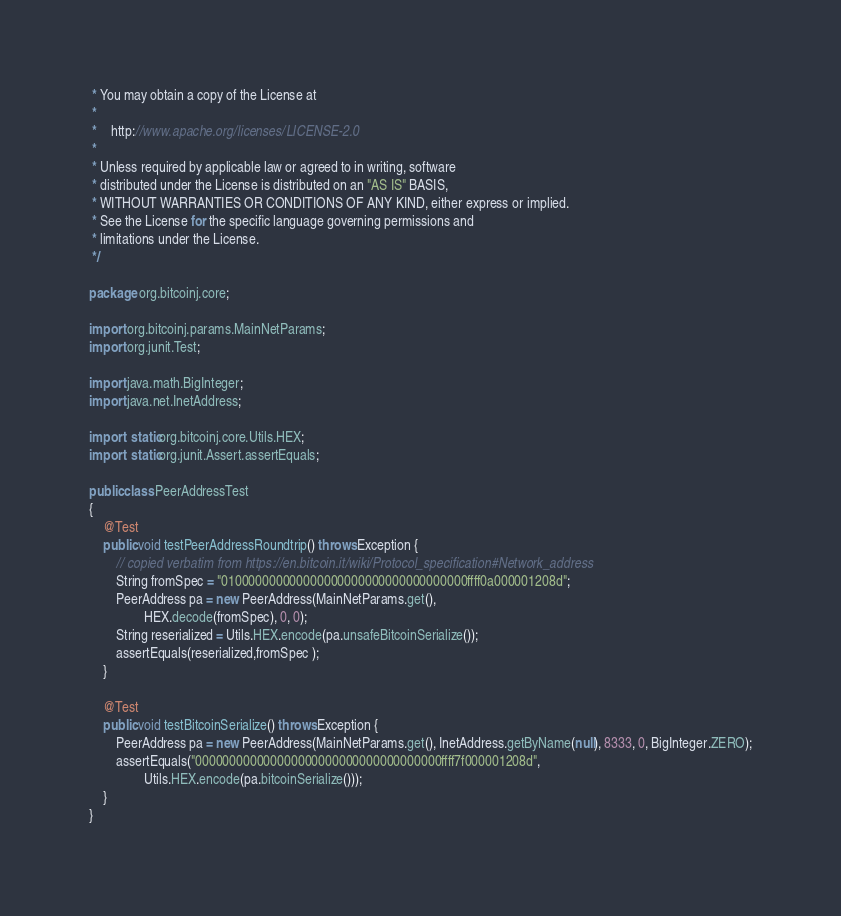Convert code to text. <code><loc_0><loc_0><loc_500><loc_500><_Java_> * You may obtain a copy of the License at
 *
 *    http://www.apache.org/licenses/LICENSE-2.0
 *
 * Unless required by applicable law or agreed to in writing, software
 * distributed under the License is distributed on an "AS IS" BASIS,
 * WITHOUT WARRANTIES OR CONDITIONS OF ANY KIND, either express or implied.
 * See the License for the specific language governing permissions and
 * limitations under the License.
 */

package org.bitcoinj.core;

import org.bitcoinj.params.MainNetParams;
import org.junit.Test;

import java.math.BigInteger;
import java.net.InetAddress;

import static org.bitcoinj.core.Utils.HEX;
import static org.junit.Assert.assertEquals;

public class PeerAddressTest
{
    @Test
    public void testPeerAddressRoundtrip() throws Exception {
        // copied verbatim from https://en.bitcoin.it/wiki/Protocol_specification#Network_address
        String fromSpec = "010000000000000000000000000000000000ffff0a000001208d";
        PeerAddress pa = new PeerAddress(MainNetParams.get(),
                HEX.decode(fromSpec), 0, 0);
        String reserialized = Utils.HEX.encode(pa.unsafeBitcoinSerialize());
        assertEquals(reserialized,fromSpec );
    }

    @Test
    public void testBitcoinSerialize() throws Exception {
        PeerAddress pa = new PeerAddress(MainNetParams.get(), InetAddress.getByName(null), 8333, 0, BigInteger.ZERO);
        assertEquals("000000000000000000000000000000000000ffff7f000001208d",
                Utils.HEX.encode(pa.bitcoinSerialize()));
    }
}
</code> 